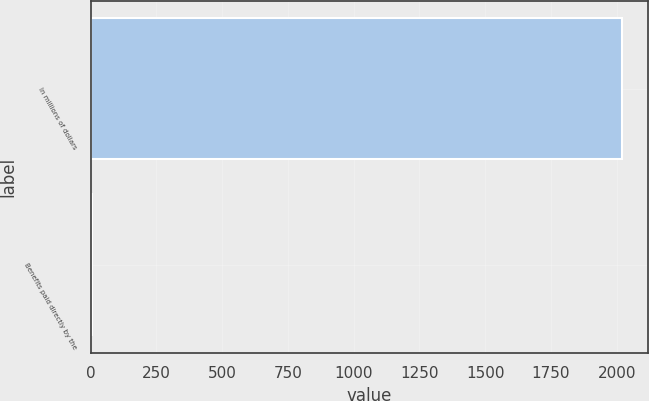<chart> <loc_0><loc_0><loc_500><loc_500><bar_chart><fcel>In millions of dollars<fcel>Benefits paid directly by the<nl><fcel>2019<fcel>6<nl></chart> 